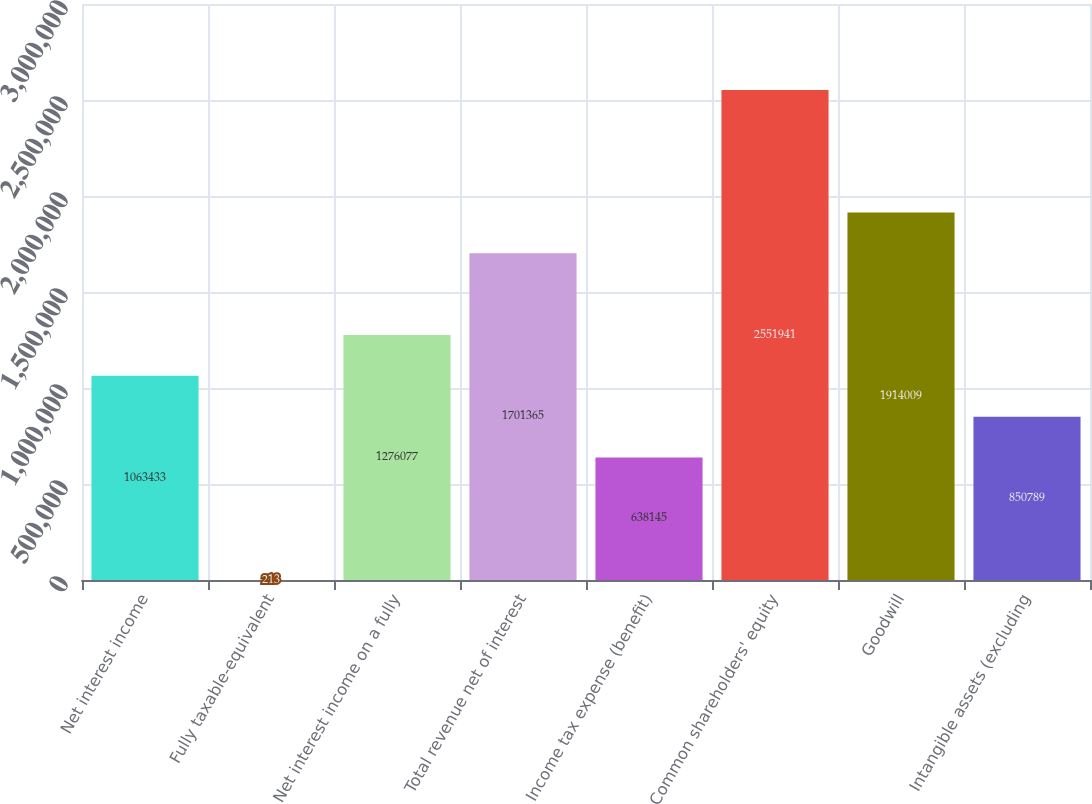<chart> <loc_0><loc_0><loc_500><loc_500><bar_chart><fcel>Net interest income<fcel>Fully taxable-equivalent<fcel>Net interest income on a fully<fcel>Total revenue net of interest<fcel>Income tax expense (benefit)<fcel>Common shareholders' equity<fcel>Goodwill<fcel>Intangible assets (excluding<nl><fcel>1.06343e+06<fcel>213<fcel>1.27608e+06<fcel>1.70136e+06<fcel>638145<fcel>2.55194e+06<fcel>1.91401e+06<fcel>850789<nl></chart> 